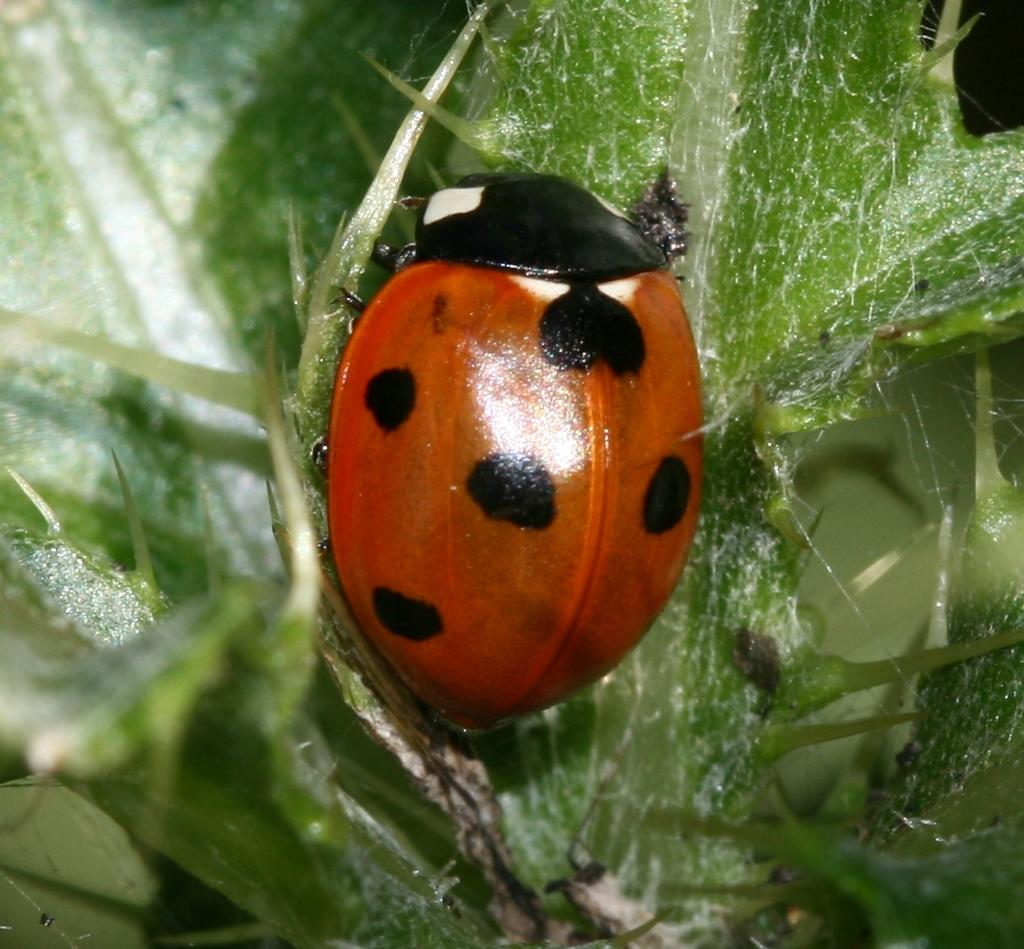What type of insect is present in the image? There is a Ladybird beetle in the image. What is the Ladybird beetle sitting on? The Ladybird beetle is sitting on a green color plant. What grade does the gate receive in the image? There is no gate present in the image, so it cannot be graded. 